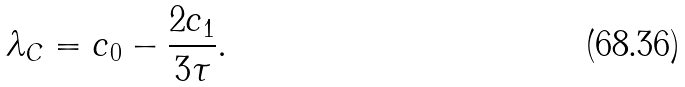Convert formula to latex. <formula><loc_0><loc_0><loc_500><loc_500>\lambda _ { C } = c _ { 0 } - \frac { 2 c _ { 1 } } { 3 \tau } .</formula> 